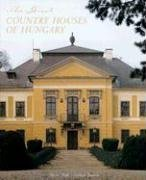What period does this house date back to, and what is its historical significance? The house shown appears to be an 18th-century baroque estate, which often carries with it a rich history as a witness to centuries of cultural and social changes. It's likely that such a house would have been owned by Hungarian nobility and played a role in the country's heritage. 